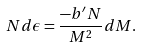<formula> <loc_0><loc_0><loc_500><loc_500>N d \epsilon = \frac { - b ^ { \prime } N } { M ^ { 2 } } d M .</formula> 